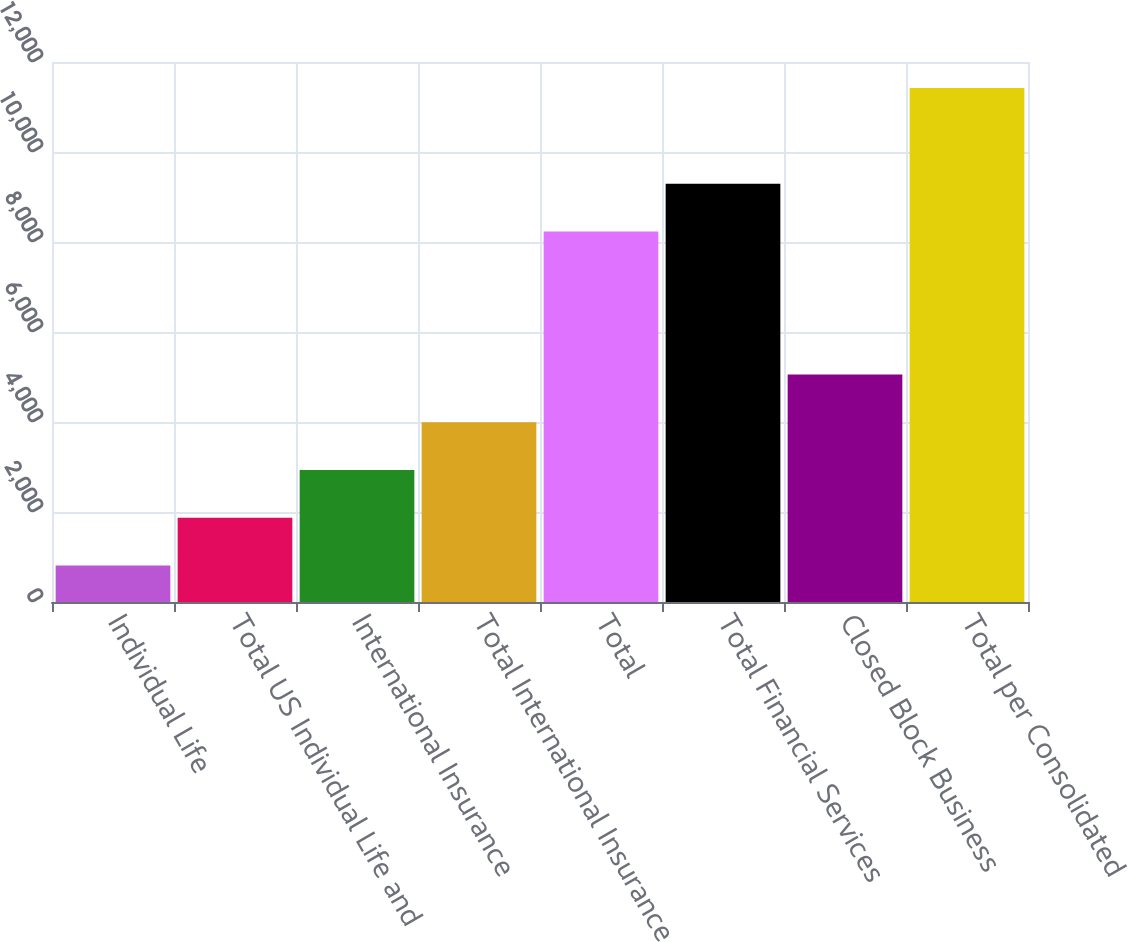Convert chart. <chart><loc_0><loc_0><loc_500><loc_500><bar_chart><fcel>Individual Life<fcel>Total US Individual Life and<fcel>International Insurance<fcel>Total International Insurance<fcel>Total<fcel>Total Financial Services<fcel>Closed Block Business<fcel>Total per Consolidated<nl><fcel>809<fcel>1870.2<fcel>2931.4<fcel>3992.6<fcel>8231<fcel>9292.2<fcel>5053.8<fcel>11421<nl></chart> 